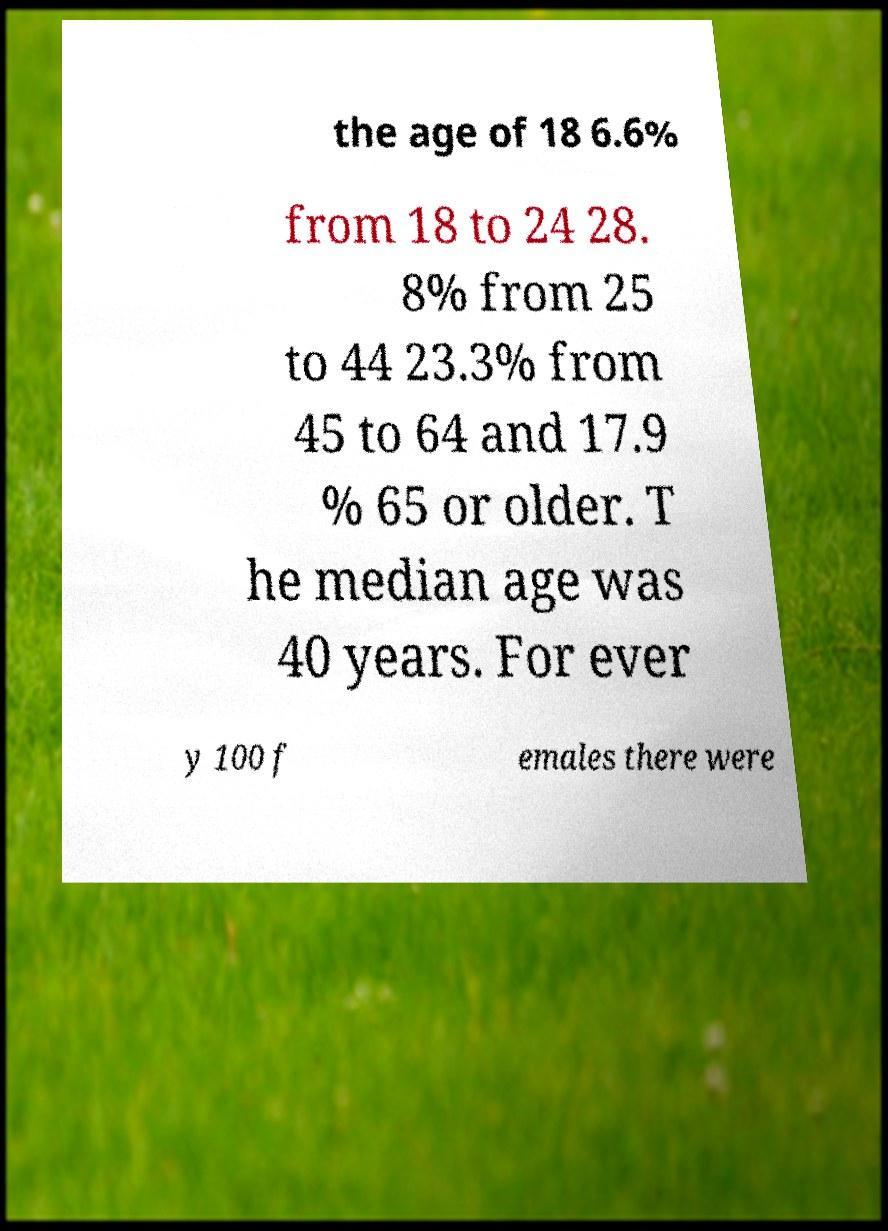Can you read and provide the text displayed in the image?This photo seems to have some interesting text. Can you extract and type it out for me? the age of 18 6.6% from 18 to 24 28. 8% from 25 to 44 23.3% from 45 to 64 and 17.9 % 65 or older. T he median age was 40 years. For ever y 100 f emales there were 